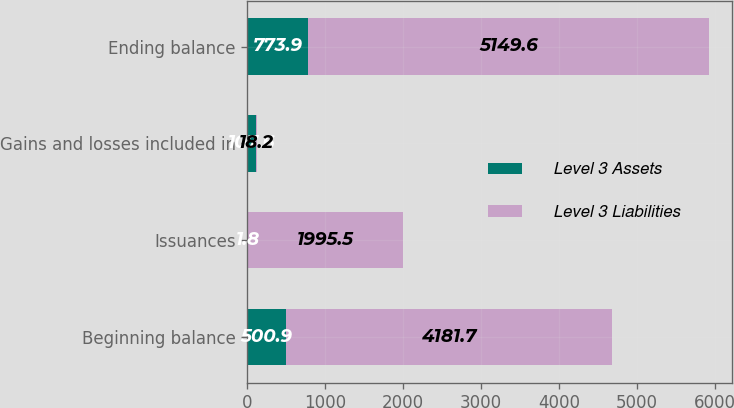Convert chart to OTSL. <chart><loc_0><loc_0><loc_500><loc_500><stacked_bar_chart><ecel><fcel>Beginning balance<fcel>Issuances<fcel>Gains and losses included in<fcel>Ending balance<nl><fcel>Level 3 Assets<fcel>500.9<fcel>1.8<fcel>107.6<fcel>773.9<nl><fcel>Level 3 Liabilities<fcel>4181.7<fcel>1995.5<fcel>18.2<fcel>5149.6<nl></chart> 